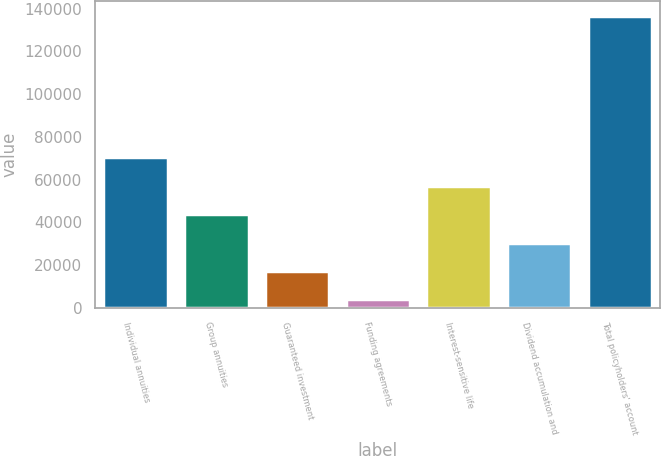Convert chart. <chart><loc_0><loc_0><loc_500><loc_500><bar_chart><fcel>Individual annuities<fcel>Group annuities<fcel>Guaranteed investment<fcel>Funding agreements<fcel>Interest-sensitive life<fcel>Dividend accumulation and<fcel>Total policyholders' account<nl><fcel>70390.5<fcel>43833.1<fcel>17275.7<fcel>3997<fcel>57111.8<fcel>30554.4<fcel>136784<nl></chart> 